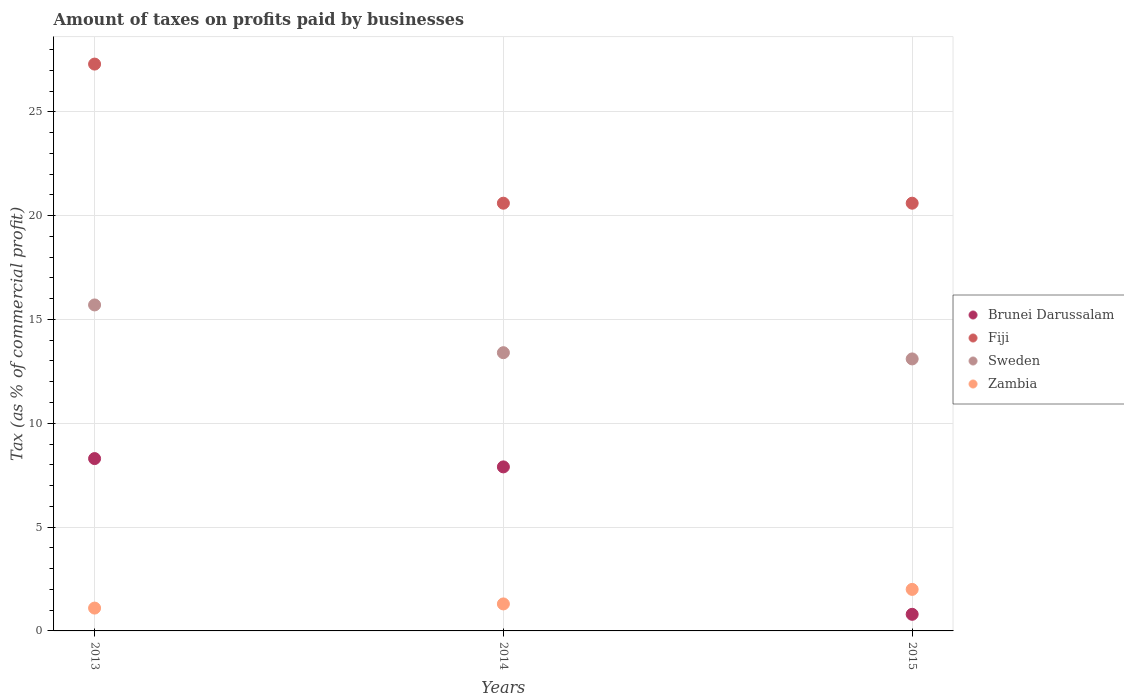How many different coloured dotlines are there?
Provide a succinct answer. 4. Is the number of dotlines equal to the number of legend labels?
Offer a terse response. Yes. What is the percentage of taxes paid by businesses in Fiji in 2014?
Offer a very short reply. 20.6. Across all years, what is the maximum percentage of taxes paid by businesses in Brunei Darussalam?
Your answer should be compact. 8.3. Across all years, what is the minimum percentage of taxes paid by businesses in Brunei Darussalam?
Ensure brevity in your answer.  0.8. In which year was the percentage of taxes paid by businesses in Zambia maximum?
Keep it short and to the point. 2015. In which year was the percentage of taxes paid by businesses in Brunei Darussalam minimum?
Offer a terse response. 2015. What is the total percentage of taxes paid by businesses in Sweden in the graph?
Your response must be concise. 42.2. What is the difference between the percentage of taxes paid by businesses in Fiji in 2015 and the percentage of taxes paid by businesses in Zambia in 2014?
Keep it short and to the point. 19.3. What is the average percentage of taxes paid by businesses in Zambia per year?
Offer a terse response. 1.47. In the year 2013, what is the difference between the percentage of taxes paid by businesses in Brunei Darussalam and percentage of taxes paid by businesses in Zambia?
Offer a very short reply. 7.2. What is the ratio of the percentage of taxes paid by businesses in Sweden in 2013 to that in 2014?
Offer a terse response. 1.17. Is the difference between the percentage of taxes paid by businesses in Brunei Darussalam in 2013 and 2014 greater than the difference between the percentage of taxes paid by businesses in Zambia in 2013 and 2014?
Ensure brevity in your answer.  Yes. What is the difference between the highest and the lowest percentage of taxes paid by businesses in Sweden?
Ensure brevity in your answer.  2.6. In how many years, is the percentage of taxes paid by businesses in Sweden greater than the average percentage of taxes paid by businesses in Sweden taken over all years?
Your answer should be very brief. 1. Is the sum of the percentage of taxes paid by businesses in Fiji in 2013 and 2015 greater than the maximum percentage of taxes paid by businesses in Zambia across all years?
Your answer should be very brief. Yes. Is it the case that in every year, the sum of the percentage of taxes paid by businesses in Sweden and percentage of taxes paid by businesses in Fiji  is greater than the sum of percentage of taxes paid by businesses in Brunei Darussalam and percentage of taxes paid by businesses in Zambia?
Your response must be concise. Yes. Is it the case that in every year, the sum of the percentage of taxes paid by businesses in Zambia and percentage of taxes paid by businesses in Brunei Darussalam  is greater than the percentage of taxes paid by businesses in Sweden?
Keep it short and to the point. No. Does the percentage of taxes paid by businesses in Sweden monotonically increase over the years?
Give a very brief answer. No. Is the percentage of taxes paid by businesses in Sweden strictly greater than the percentage of taxes paid by businesses in Brunei Darussalam over the years?
Your response must be concise. Yes. Is the percentage of taxes paid by businesses in Fiji strictly less than the percentage of taxes paid by businesses in Zambia over the years?
Offer a terse response. No. What is the difference between two consecutive major ticks on the Y-axis?
Provide a short and direct response. 5. Does the graph contain grids?
Ensure brevity in your answer.  Yes. How many legend labels are there?
Keep it short and to the point. 4. How are the legend labels stacked?
Your answer should be compact. Vertical. What is the title of the graph?
Ensure brevity in your answer.  Amount of taxes on profits paid by businesses. Does "Nepal" appear as one of the legend labels in the graph?
Ensure brevity in your answer.  No. What is the label or title of the X-axis?
Offer a terse response. Years. What is the label or title of the Y-axis?
Offer a terse response. Tax (as % of commercial profit). What is the Tax (as % of commercial profit) of Fiji in 2013?
Provide a short and direct response. 27.3. What is the Tax (as % of commercial profit) of Brunei Darussalam in 2014?
Provide a short and direct response. 7.9. What is the Tax (as % of commercial profit) of Fiji in 2014?
Offer a terse response. 20.6. What is the Tax (as % of commercial profit) in Sweden in 2014?
Provide a short and direct response. 13.4. What is the Tax (as % of commercial profit) of Fiji in 2015?
Give a very brief answer. 20.6. What is the Tax (as % of commercial profit) of Sweden in 2015?
Offer a very short reply. 13.1. Across all years, what is the maximum Tax (as % of commercial profit) of Brunei Darussalam?
Keep it short and to the point. 8.3. Across all years, what is the maximum Tax (as % of commercial profit) of Fiji?
Offer a very short reply. 27.3. Across all years, what is the maximum Tax (as % of commercial profit) of Zambia?
Make the answer very short. 2. Across all years, what is the minimum Tax (as % of commercial profit) of Fiji?
Your answer should be compact. 20.6. Across all years, what is the minimum Tax (as % of commercial profit) of Zambia?
Give a very brief answer. 1.1. What is the total Tax (as % of commercial profit) of Fiji in the graph?
Ensure brevity in your answer.  68.5. What is the total Tax (as % of commercial profit) in Sweden in the graph?
Offer a very short reply. 42.2. What is the difference between the Tax (as % of commercial profit) of Brunei Darussalam in 2013 and that in 2014?
Provide a short and direct response. 0.4. What is the difference between the Tax (as % of commercial profit) of Brunei Darussalam in 2013 and that in 2015?
Offer a very short reply. 7.5. What is the difference between the Tax (as % of commercial profit) in Brunei Darussalam in 2014 and that in 2015?
Your response must be concise. 7.1. What is the difference between the Tax (as % of commercial profit) in Brunei Darussalam in 2013 and the Tax (as % of commercial profit) in Sweden in 2014?
Provide a succinct answer. -5.1. What is the difference between the Tax (as % of commercial profit) of Fiji in 2013 and the Tax (as % of commercial profit) of Sweden in 2014?
Offer a very short reply. 13.9. What is the difference between the Tax (as % of commercial profit) of Sweden in 2013 and the Tax (as % of commercial profit) of Zambia in 2014?
Your answer should be very brief. 14.4. What is the difference between the Tax (as % of commercial profit) in Brunei Darussalam in 2013 and the Tax (as % of commercial profit) in Fiji in 2015?
Offer a very short reply. -12.3. What is the difference between the Tax (as % of commercial profit) of Brunei Darussalam in 2013 and the Tax (as % of commercial profit) of Sweden in 2015?
Your response must be concise. -4.8. What is the difference between the Tax (as % of commercial profit) in Brunei Darussalam in 2013 and the Tax (as % of commercial profit) in Zambia in 2015?
Your response must be concise. 6.3. What is the difference between the Tax (as % of commercial profit) in Fiji in 2013 and the Tax (as % of commercial profit) in Sweden in 2015?
Give a very brief answer. 14.2. What is the difference between the Tax (as % of commercial profit) of Fiji in 2013 and the Tax (as % of commercial profit) of Zambia in 2015?
Keep it short and to the point. 25.3. What is the difference between the Tax (as % of commercial profit) in Sweden in 2013 and the Tax (as % of commercial profit) in Zambia in 2015?
Your answer should be very brief. 13.7. What is the difference between the Tax (as % of commercial profit) in Fiji in 2014 and the Tax (as % of commercial profit) in Sweden in 2015?
Offer a very short reply. 7.5. What is the average Tax (as % of commercial profit) in Brunei Darussalam per year?
Your answer should be very brief. 5.67. What is the average Tax (as % of commercial profit) of Fiji per year?
Give a very brief answer. 22.83. What is the average Tax (as % of commercial profit) of Sweden per year?
Your answer should be very brief. 14.07. What is the average Tax (as % of commercial profit) in Zambia per year?
Ensure brevity in your answer.  1.47. In the year 2013, what is the difference between the Tax (as % of commercial profit) in Brunei Darussalam and Tax (as % of commercial profit) in Fiji?
Your response must be concise. -19. In the year 2013, what is the difference between the Tax (as % of commercial profit) in Brunei Darussalam and Tax (as % of commercial profit) in Sweden?
Your answer should be compact. -7.4. In the year 2013, what is the difference between the Tax (as % of commercial profit) of Brunei Darussalam and Tax (as % of commercial profit) of Zambia?
Keep it short and to the point. 7.2. In the year 2013, what is the difference between the Tax (as % of commercial profit) of Fiji and Tax (as % of commercial profit) of Zambia?
Ensure brevity in your answer.  26.2. In the year 2013, what is the difference between the Tax (as % of commercial profit) in Sweden and Tax (as % of commercial profit) in Zambia?
Offer a very short reply. 14.6. In the year 2014, what is the difference between the Tax (as % of commercial profit) of Fiji and Tax (as % of commercial profit) of Zambia?
Provide a succinct answer. 19.3. In the year 2015, what is the difference between the Tax (as % of commercial profit) of Brunei Darussalam and Tax (as % of commercial profit) of Fiji?
Your answer should be very brief. -19.8. In the year 2015, what is the difference between the Tax (as % of commercial profit) in Brunei Darussalam and Tax (as % of commercial profit) in Zambia?
Keep it short and to the point. -1.2. In the year 2015, what is the difference between the Tax (as % of commercial profit) of Fiji and Tax (as % of commercial profit) of Zambia?
Make the answer very short. 18.6. In the year 2015, what is the difference between the Tax (as % of commercial profit) in Sweden and Tax (as % of commercial profit) in Zambia?
Your answer should be very brief. 11.1. What is the ratio of the Tax (as % of commercial profit) of Brunei Darussalam in 2013 to that in 2014?
Give a very brief answer. 1.05. What is the ratio of the Tax (as % of commercial profit) of Fiji in 2013 to that in 2014?
Provide a short and direct response. 1.33. What is the ratio of the Tax (as % of commercial profit) of Sweden in 2013 to that in 2014?
Give a very brief answer. 1.17. What is the ratio of the Tax (as % of commercial profit) of Zambia in 2013 to that in 2014?
Provide a succinct answer. 0.85. What is the ratio of the Tax (as % of commercial profit) of Brunei Darussalam in 2013 to that in 2015?
Your response must be concise. 10.38. What is the ratio of the Tax (as % of commercial profit) in Fiji in 2013 to that in 2015?
Your answer should be very brief. 1.33. What is the ratio of the Tax (as % of commercial profit) of Sweden in 2013 to that in 2015?
Your response must be concise. 1.2. What is the ratio of the Tax (as % of commercial profit) of Zambia in 2013 to that in 2015?
Provide a short and direct response. 0.55. What is the ratio of the Tax (as % of commercial profit) in Brunei Darussalam in 2014 to that in 2015?
Give a very brief answer. 9.88. What is the ratio of the Tax (as % of commercial profit) in Fiji in 2014 to that in 2015?
Ensure brevity in your answer.  1. What is the ratio of the Tax (as % of commercial profit) of Sweden in 2014 to that in 2015?
Keep it short and to the point. 1.02. What is the ratio of the Tax (as % of commercial profit) of Zambia in 2014 to that in 2015?
Make the answer very short. 0.65. What is the difference between the highest and the second highest Tax (as % of commercial profit) in Sweden?
Provide a short and direct response. 2.3. What is the difference between the highest and the lowest Tax (as % of commercial profit) in Zambia?
Make the answer very short. 0.9. 